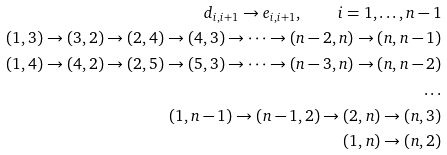Convert formula to latex. <formula><loc_0><loc_0><loc_500><loc_500>d _ { i , i + 1 } \to e _ { i , i + 1 } , \quad i = 1 , \dots , n - 1 \\ ( 1 , 3 ) \to ( 3 , 2 ) \to ( 2 , 4 ) \to ( 4 , 3 ) \to \dots \to ( n - 2 , n ) \to ( n , n - 1 ) \\ ( 1 , 4 ) \to ( 4 , 2 ) \to ( 2 , 5 ) \to ( 5 , 3 ) \to \dots \to ( n - 3 , n ) \to ( n , n - 2 ) \\ \dots \\ ( 1 , n - 1 ) \to ( n - 1 , 2 ) \to ( 2 , n ) \to ( n , 3 ) \\ ( 1 , n ) \to ( n , 2 )</formula> 